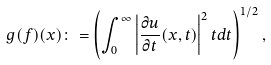Convert formula to latex. <formula><loc_0><loc_0><loc_500><loc_500>g ( f ) ( x ) \colon = \left ( \int _ { 0 } ^ { \infty } \left | \frac { \partial u } { \partial t } ( x , t ) \right | ^ { 2 } t d t \right ) ^ { 1 / 2 } ,</formula> 